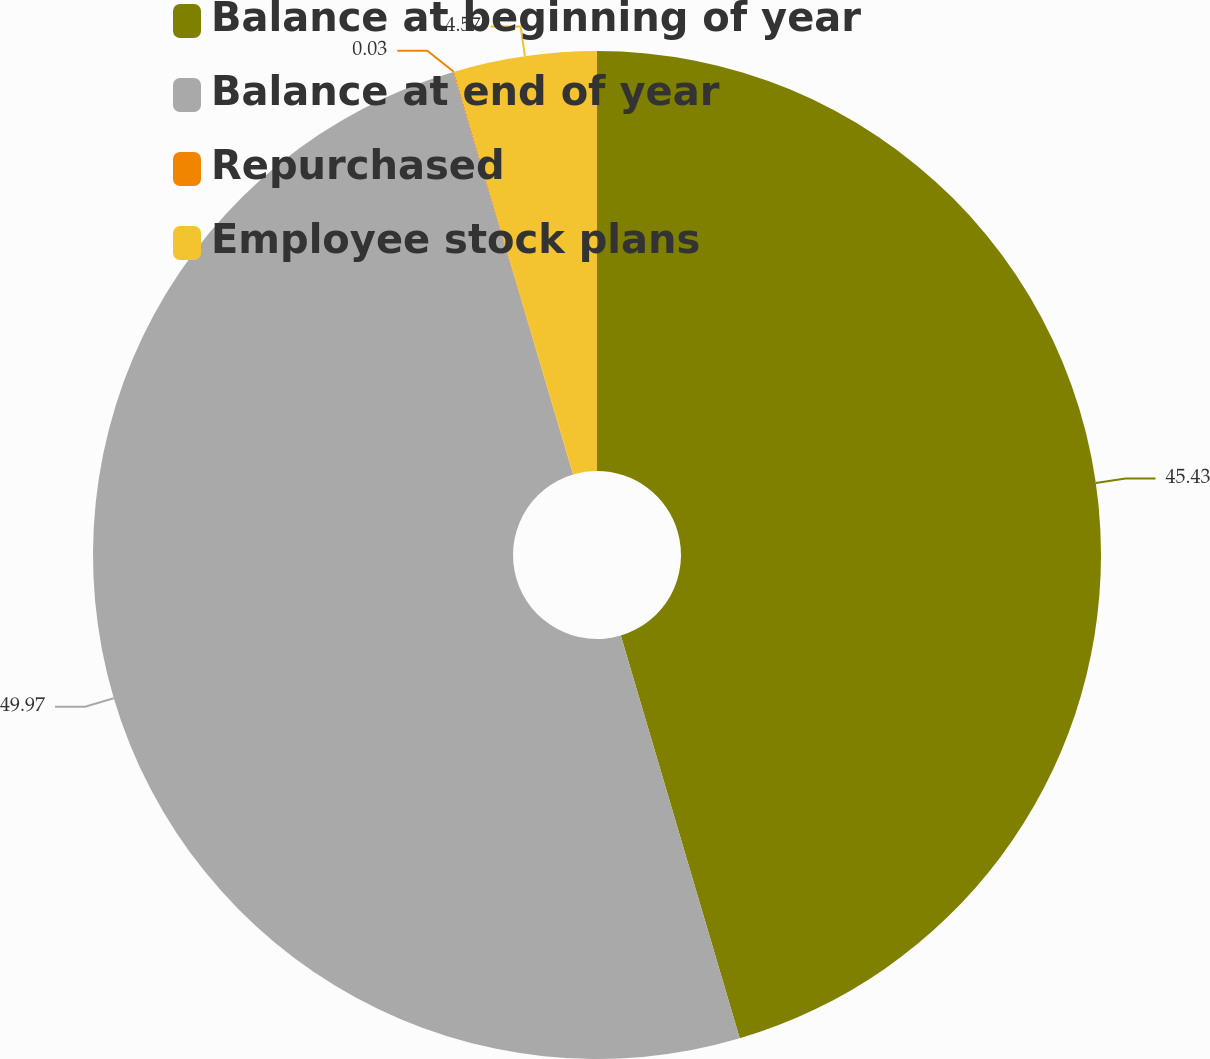Convert chart to OTSL. <chart><loc_0><loc_0><loc_500><loc_500><pie_chart><fcel>Balance at beginning of year<fcel>Balance at end of year<fcel>Repurchased<fcel>Employee stock plans<nl><fcel>45.43%<fcel>49.97%<fcel>0.03%<fcel>4.57%<nl></chart> 